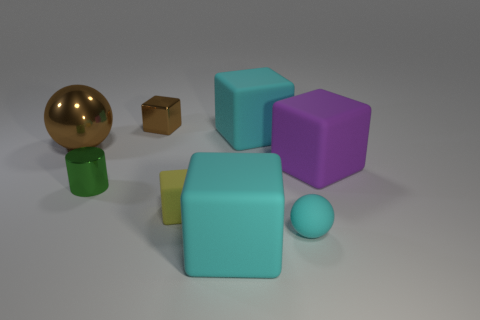Subtract all yellow blocks. How many blocks are left? 4 Subtract all metal cubes. How many cubes are left? 4 Subtract all red cubes. Subtract all blue balls. How many cubes are left? 5 Add 2 small shiny things. How many objects exist? 10 Subtract all spheres. How many objects are left? 6 Subtract 1 brown spheres. How many objects are left? 7 Subtract all big yellow metal cylinders. Subtract all brown metallic things. How many objects are left? 6 Add 4 metal cylinders. How many metal cylinders are left? 5 Add 1 brown metallic spheres. How many brown metallic spheres exist? 2 